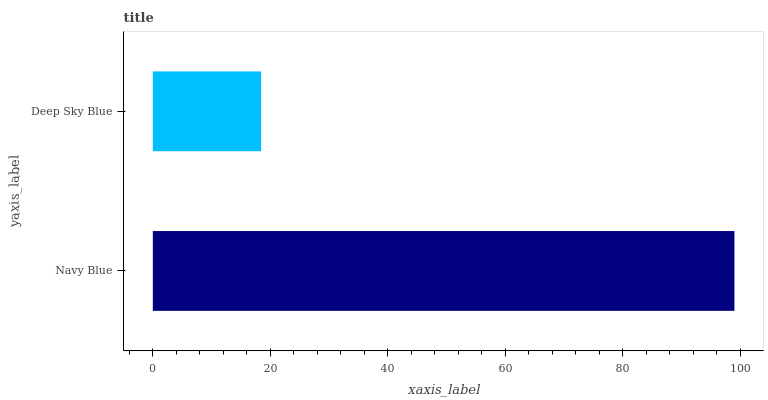Is Deep Sky Blue the minimum?
Answer yes or no. Yes. Is Navy Blue the maximum?
Answer yes or no. Yes. Is Deep Sky Blue the maximum?
Answer yes or no. No. Is Navy Blue greater than Deep Sky Blue?
Answer yes or no. Yes. Is Deep Sky Blue less than Navy Blue?
Answer yes or no. Yes. Is Deep Sky Blue greater than Navy Blue?
Answer yes or no. No. Is Navy Blue less than Deep Sky Blue?
Answer yes or no. No. Is Navy Blue the high median?
Answer yes or no. Yes. Is Deep Sky Blue the low median?
Answer yes or no. Yes. Is Deep Sky Blue the high median?
Answer yes or no. No. Is Navy Blue the low median?
Answer yes or no. No. 